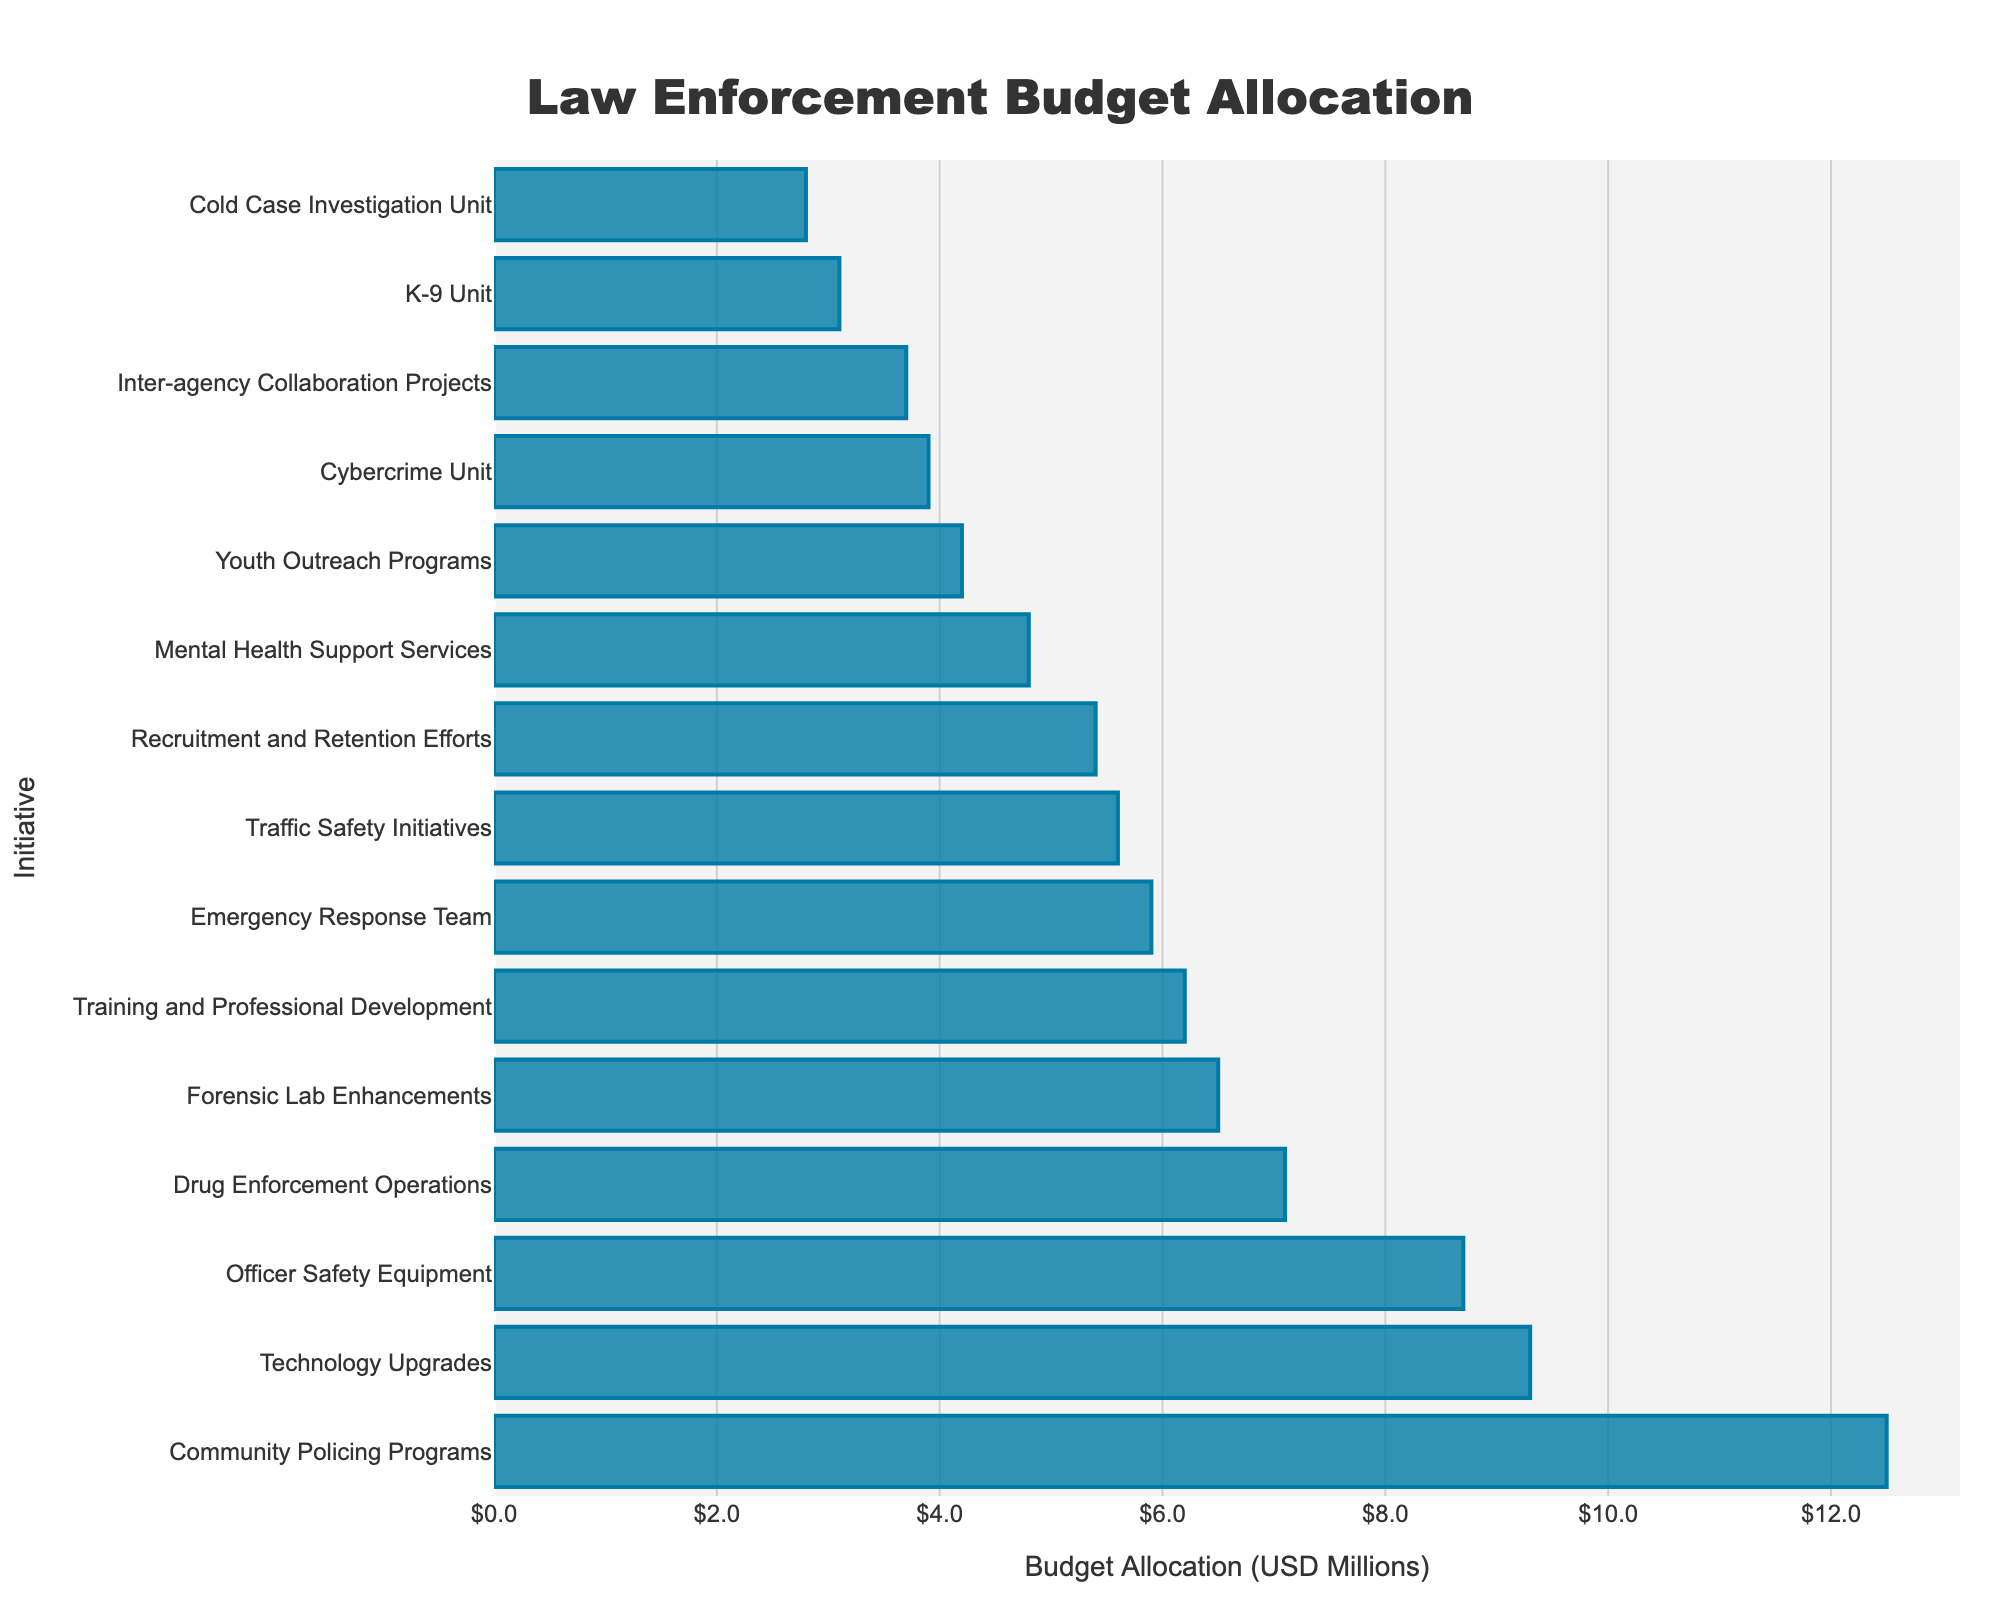Which initiative has the highest budget allocation? Look at the top bar in the figure which represents the highest value. The top bar corresponds to the "Community Policing Programs" initiative.
Answer: Community Policing Programs Which initiative has the lowest budget allocation? Look at the bottom bar in the figure which represents the lowest value. The bottom bar corresponds to the "Cold Case Investigation Unit" initiative.
Answer: Cold Case Investigation Unit What is the total budget allocation for Technology Upgrades and Officer Safety Equipment? Identify the bars for "Technology Upgrades" and "Officer Safety Equipment" and sum their values. The figures are 9.3 and 8.7 million, respectively. Adding these gives 9.3 + 8.7 = 18.0.
Answer: 18.0 million Is the budget allocation for Drug Enforcement Operations greater than Cybercrime Unit? Compare the lengths of the bars for "Drug Enforcement Operations" and "Cybercrime Unit". "Drug Enforcement Operations" (7.1 million) is greater than "Cybercrime Unit" (3.9 million).
Answer: Yes Which initiatives have a budget allocation less than 5 million USD? Identify and list all bars that are shorter than the 5 million mark. These initiatives are "Mental Health Support Services" (4.8), "Cybercrime Unit" (3.9), "Cold Case Investigation Unit" (2.8), "Youth Outreach Programs" (4.2), "K-9 Unit" (3.1), and "Inter-agency Collaboration Projects" (3.7).
Answer: Mental Health Support Services, Cybercrime Unit, Cold Case Investigation Unit, Youth Outreach Programs, K-9 Unit, Inter-agency Collaboration Projects How much more is allocated to Community Policing Programs than Training and Professional Development? Find the values for "Community Policing Programs" (12.5 million) and "Training and Professional Development" (6.2 million). Subtract the latter from the former: 12.5 - 6.2 = 6.3.
Answer: 6.3 million What is the average budget allocation for the top three initiatives? Identify the top three initiatives by reading the figure: "Community Policing Programs" (12.5), "Technology Upgrades" (9.3), and "Officer Safety Equipment" (8.7). Calculate the average: (12.5 + 9.3 + 8.7) / 3 = 30.5 / 3 = 10.17.
Answer: 10.17 million Which has a higher budget allocation: Recruitment and Retention Efforts or Emergency Response Team? Compare the lengths of the bars for "Recruitment and Retention Efforts" (5.4 million) and "Emergency Response Team" (5.9 million). The "Emergency Response Team" has a higher allocation.
Answer: Emergency Response Team Which initiative has a budget closest to the median of all budget allocations? To find the median, the data points need to be sorted: 2.8, 3.1, 3.7, 3.9, 4.2, 4.8, 5.4, 5.6, 5.9, 6.2, 6.5, 7.1, 8.7, 9.3, 12.5. The median value is the 8th in the sorted list: 5.6 million (Traffic Safety Initiatives).
Answer: Traffic Safety Initiatives How many initiatives have a budget allocation that is greater than the average funding for all initiatives? First, calculate the average allocation. Sum all values: 12.5 + 8.7 + 6.2 + 9.3 + 4.8 + 7.1 + 5.6 + 3.9 + 2.8 + 4.2 + 6.5 + 5.9 + 3.1 + 5.4 + 3.7 = 89.7 million. Divide by the number of initiatives (15): 89.7 / 15 = 5.98 million. Count the initiatives with allocations greater than 5.98: Community Policing Programs, Officer Safety Equipment, Technology Upgrades, Forensic Lab Enhancements, Drug Enforcement Operations, Training and Professional Development, Emergency Response Team, Traffic Safety Initiatives. The count is 8.
Answer: 8 